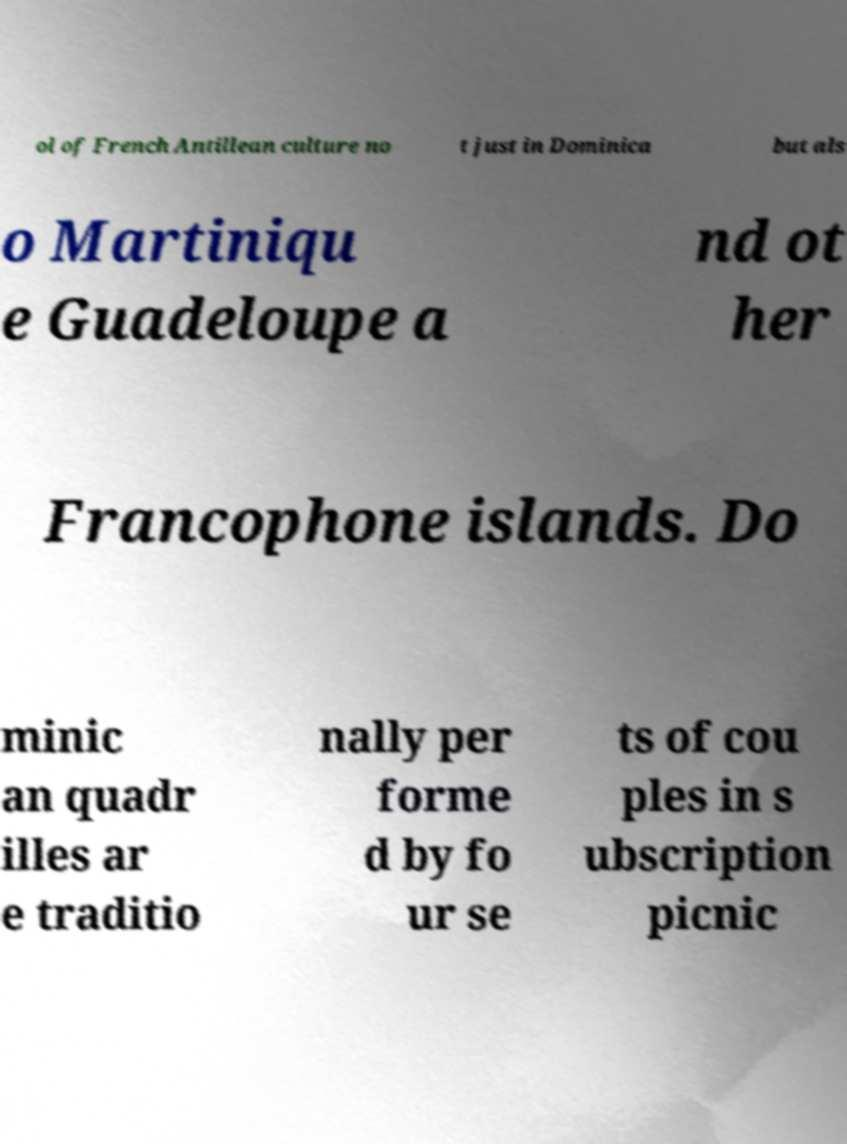Please read and relay the text visible in this image. What does it say? ol of French Antillean culture no t just in Dominica but als o Martiniqu e Guadeloupe a nd ot her Francophone islands. Do minic an quadr illes ar e traditio nally per forme d by fo ur se ts of cou ples in s ubscription picnic 